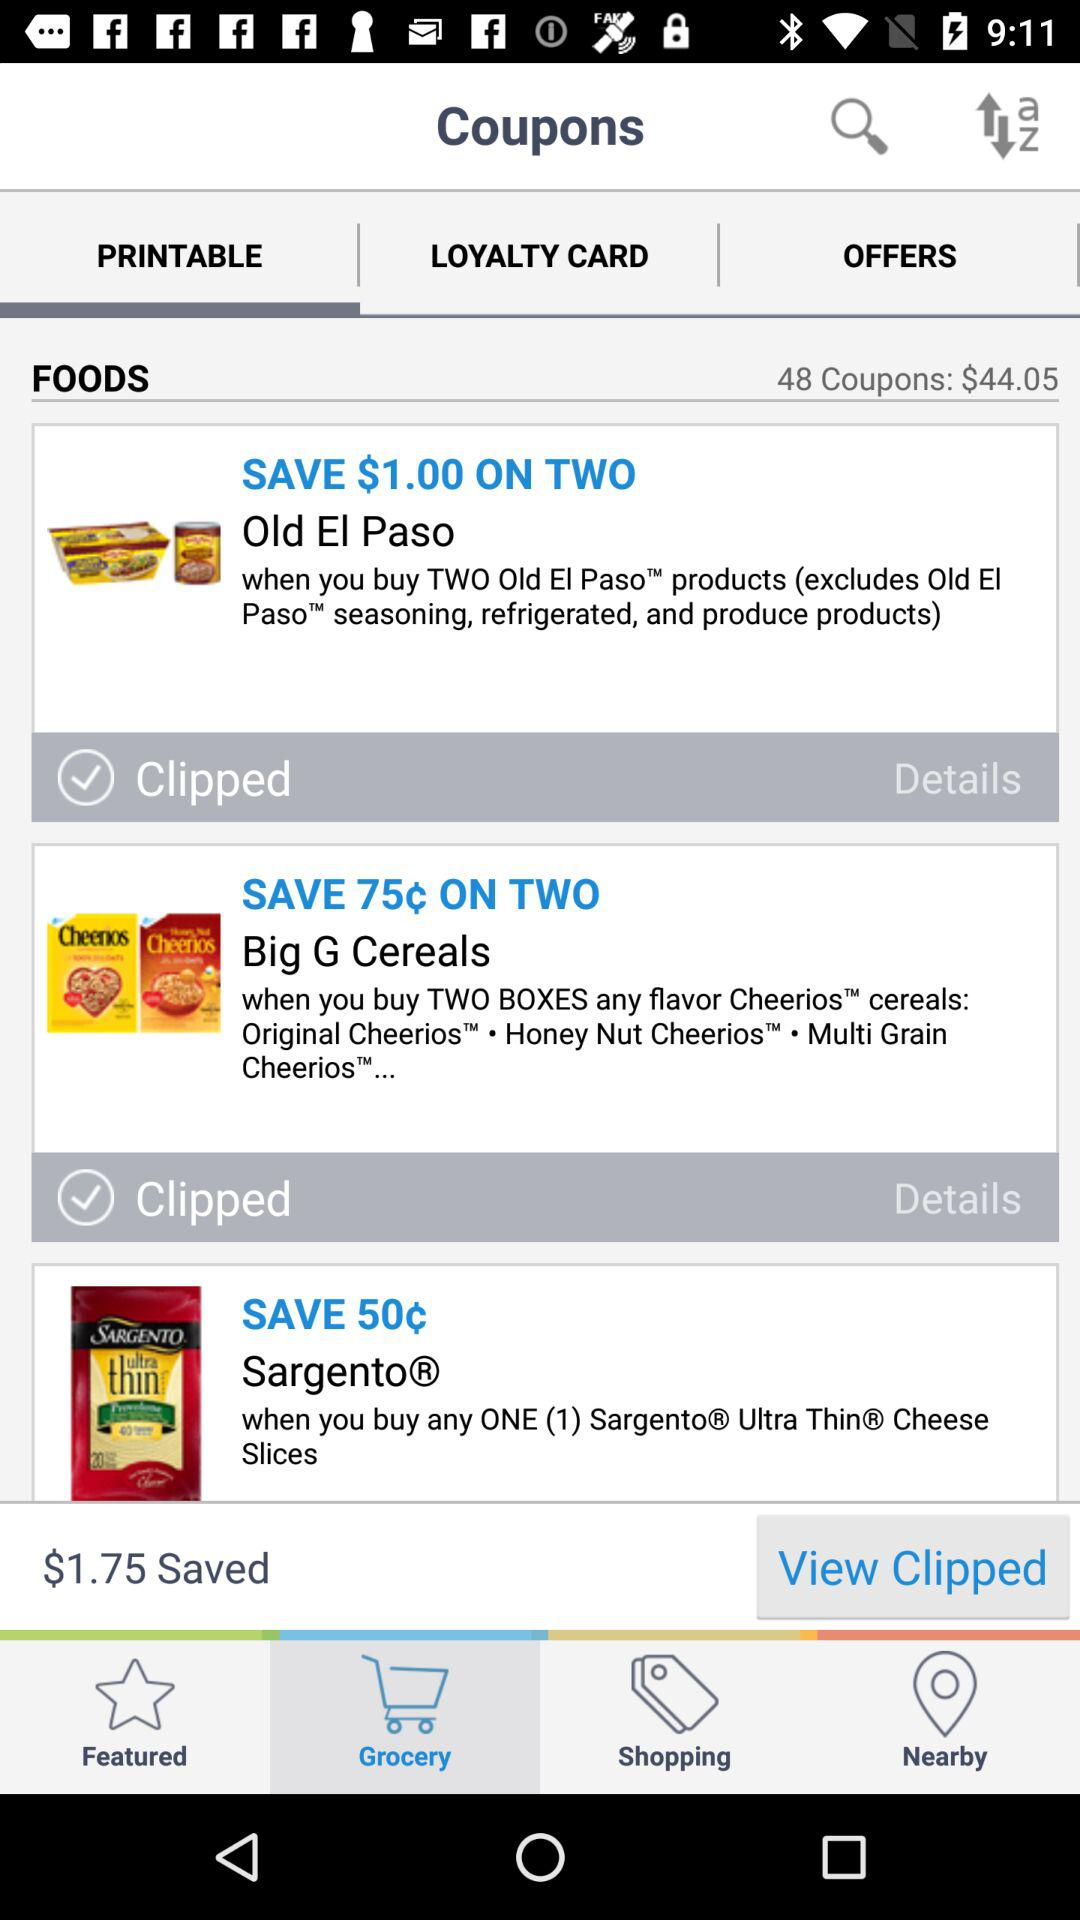What's the saved amount? The saved amount is $1.75. 